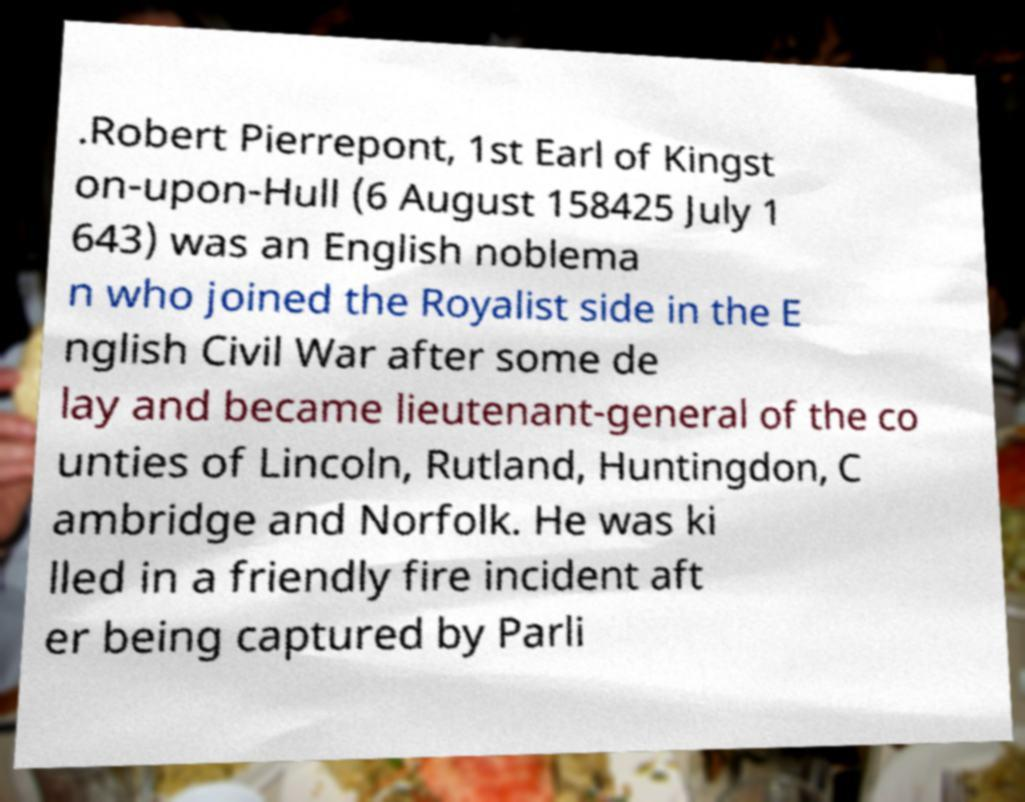For documentation purposes, I need the text within this image transcribed. Could you provide that? .Robert Pierrepont, 1st Earl of Kingst on-upon-Hull (6 August 158425 July 1 643) was an English noblema n who joined the Royalist side in the E nglish Civil War after some de lay and became lieutenant-general of the co unties of Lincoln, Rutland, Huntingdon, C ambridge and Norfolk. He was ki lled in a friendly fire incident aft er being captured by Parli 